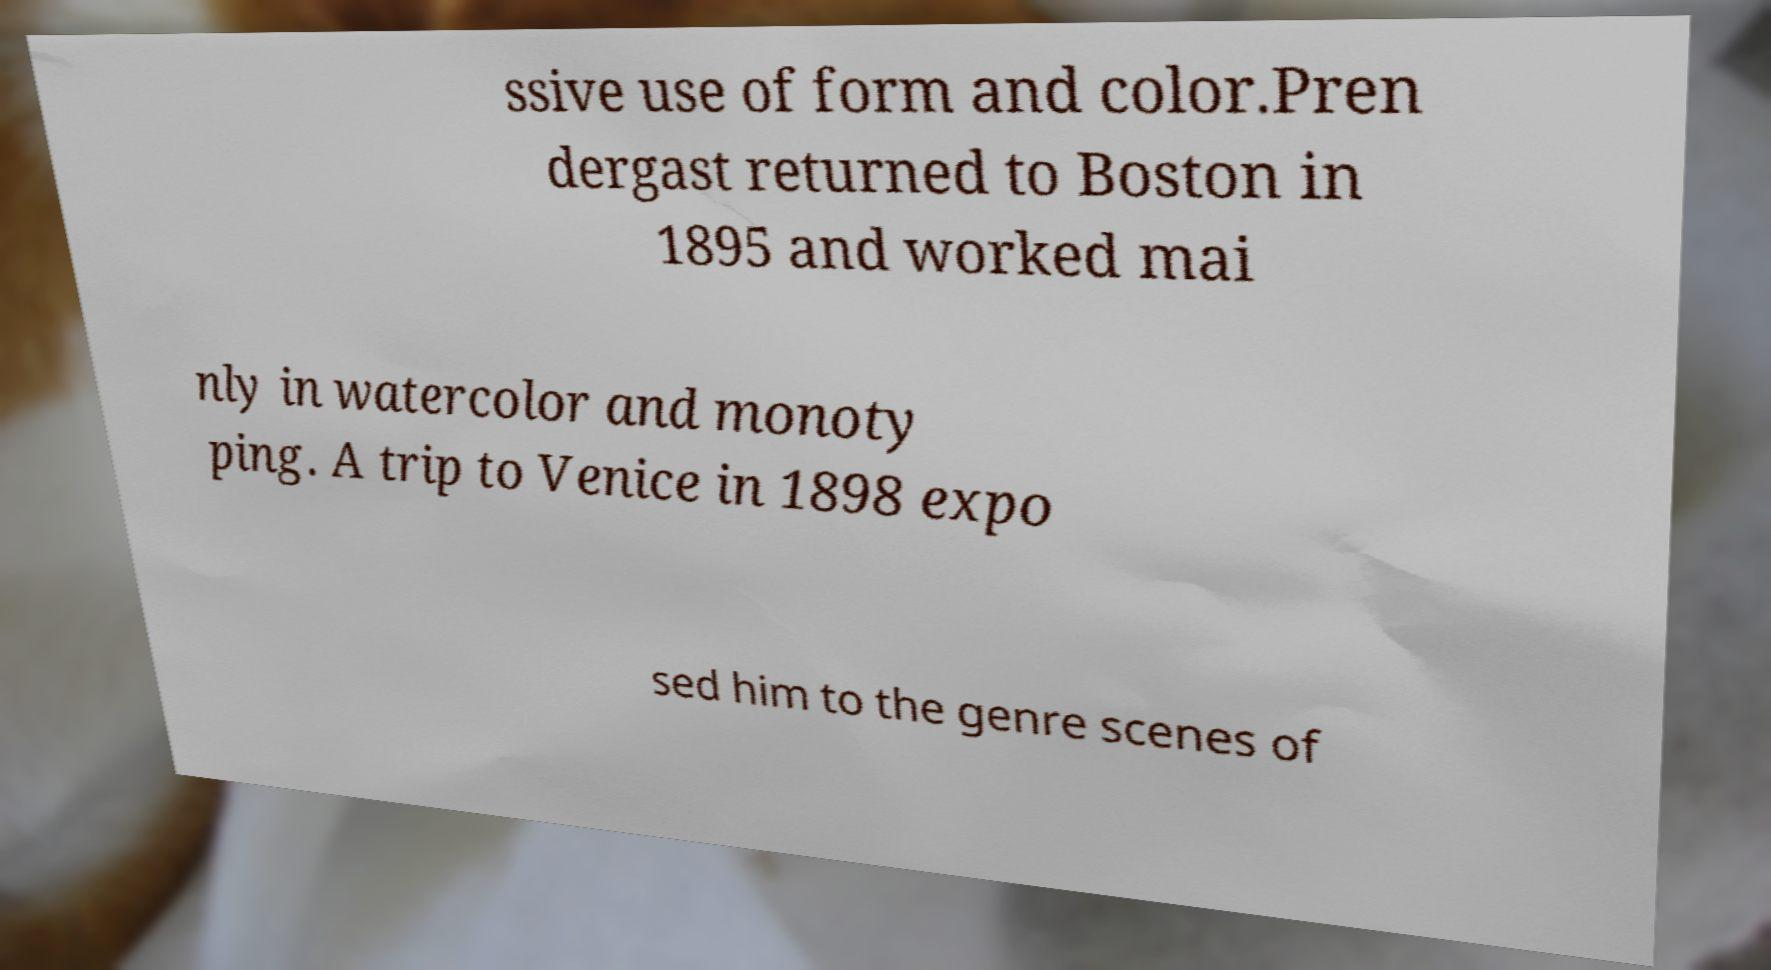There's text embedded in this image that I need extracted. Can you transcribe it verbatim? ssive use of form and color.Pren dergast returned to Boston in 1895 and worked mai nly in watercolor and monoty ping. A trip to Venice in 1898 expo sed him to the genre scenes of 